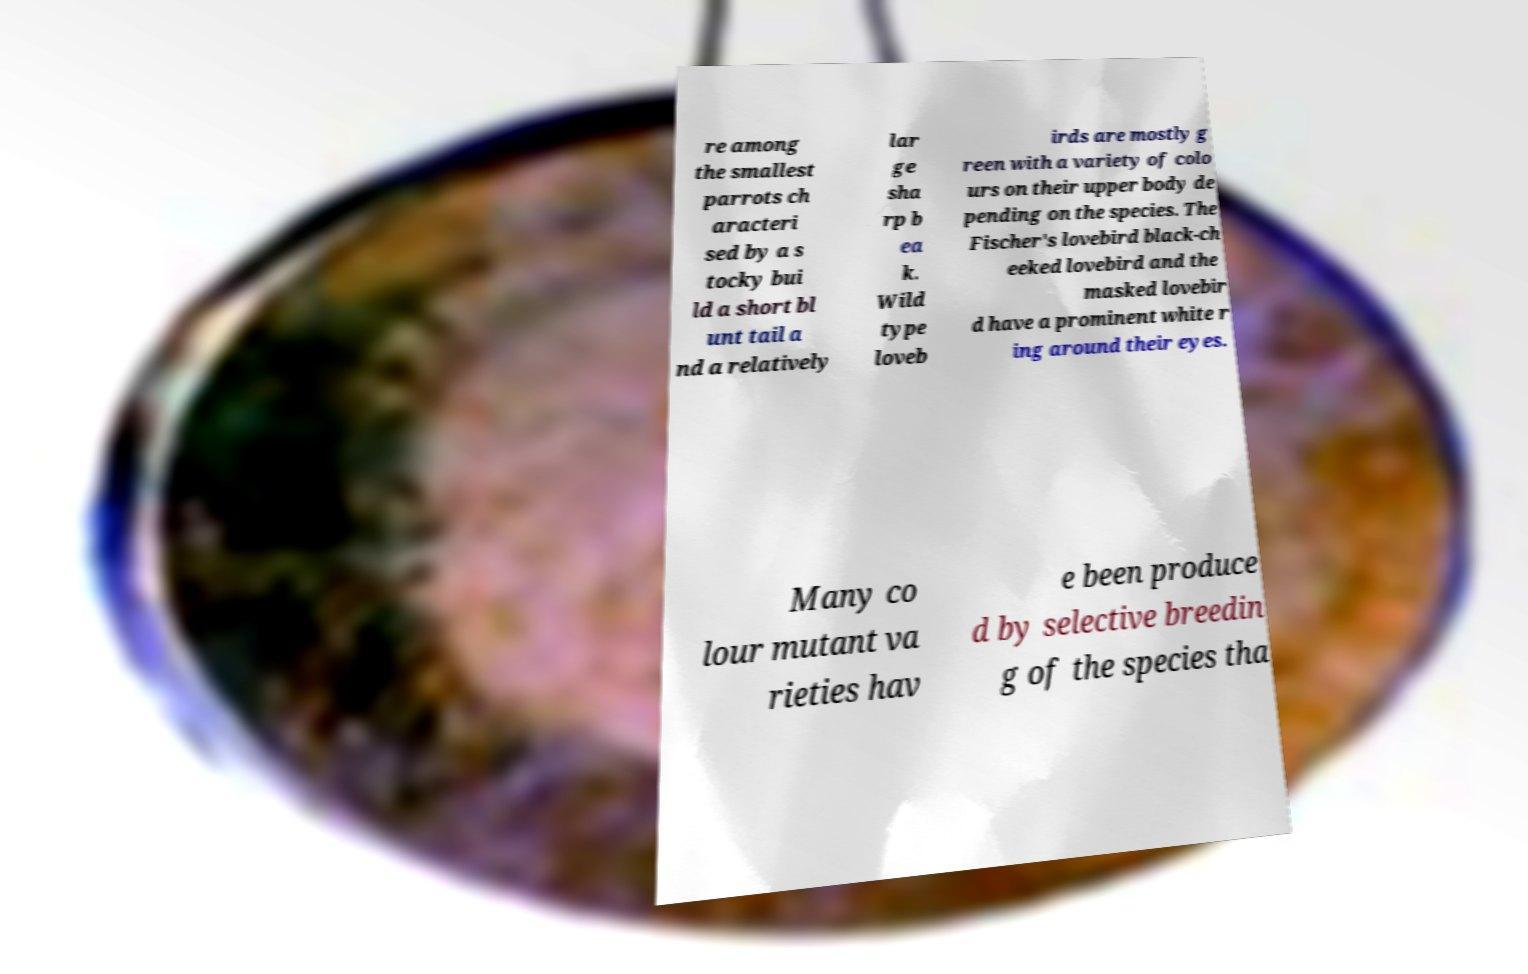Can you read and provide the text displayed in the image?This photo seems to have some interesting text. Can you extract and type it out for me? re among the smallest parrots ch aracteri sed by a s tocky bui ld a short bl unt tail a nd a relatively lar ge sha rp b ea k. Wild type loveb irds are mostly g reen with a variety of colo urs on their upper body de pending on the species. The Fischer's lovebird black-ch eeked lovebird and the masked lovebir d have a prominent white r ing around their eyes. Many co lour mutant va rieties hav e been produce d by selective breedin g of the species tha 